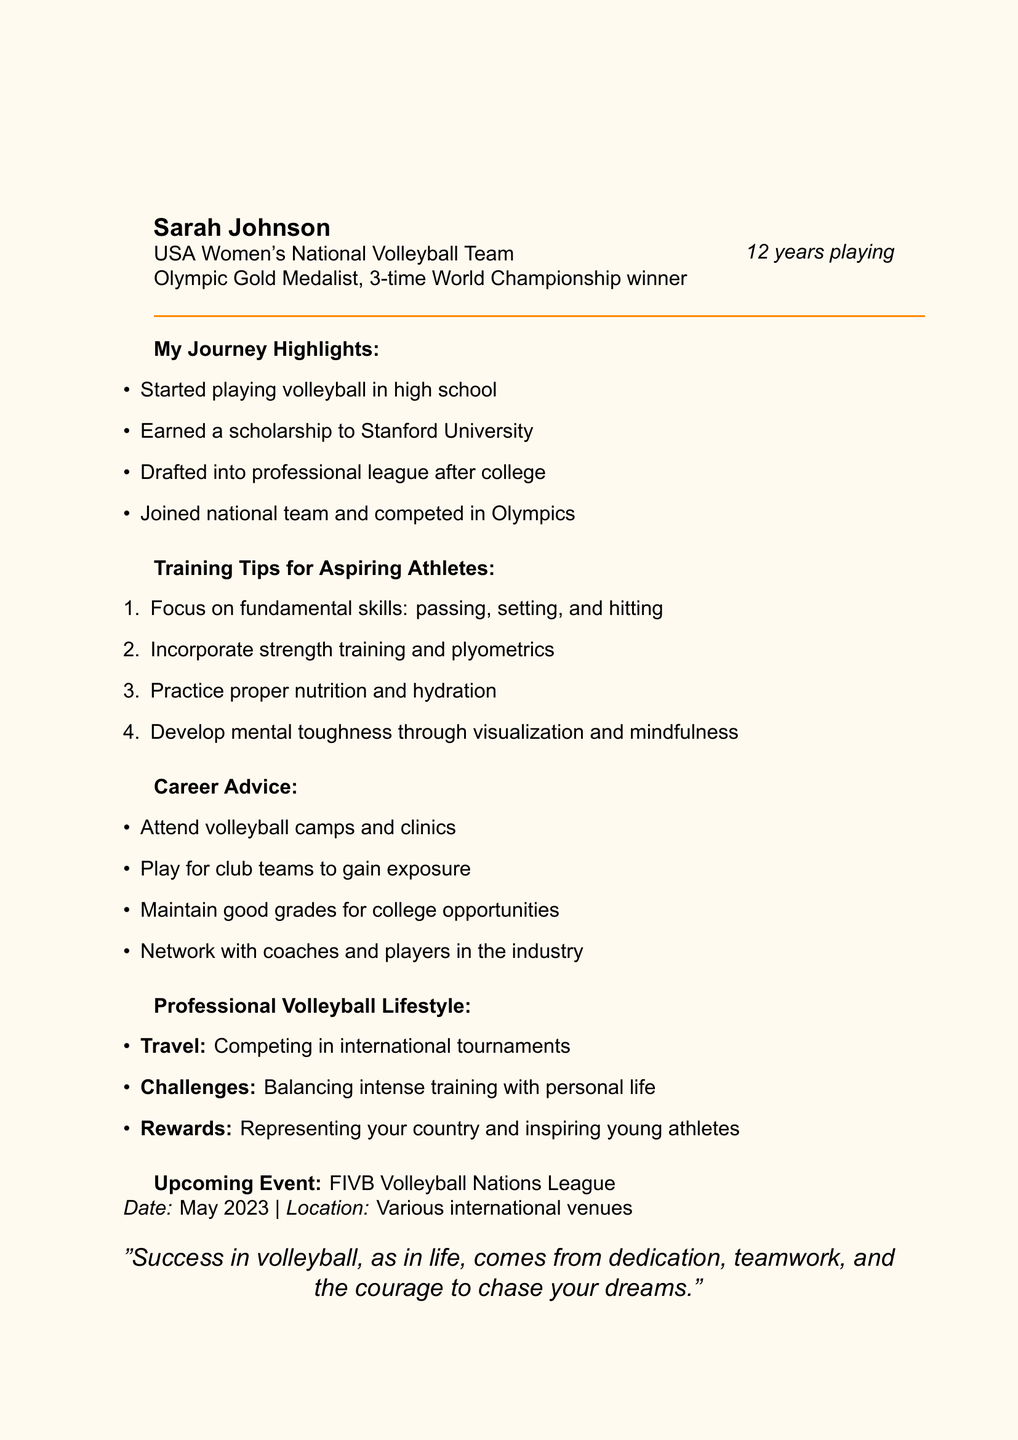What is the title of the newsletter? The title of the newsletter is stated at the beginning and is "Spike Your Dreams: Sarah Johnson's Volleyball Journey."
Answer: Spike Your Dreams: Sarah Johnson's Volleyball Journey Who is the author of the newsletter? The newsletter is written by Sarah Johnson, who is a professional volleyball player.
Answer: Sarah Johnson What achievements does Sarah Johnson have? The document lists her major achievements, including being an Olympic Gold Medalist and a 3-time World Championship winner.
Answer: Olympic Gold Medalist, 3-time World Championship winner How many years has Sarah Johnson been playing volleyball? The document states that Sarah has been playing volleyball for 12 years.
Answer: 12 years What educational institution did Sarah Johnson earn a scholarship to? The document mentions that she earned a scholarship to Stanford University.
Answer: Stanford University What are two training tips provided in the newsletter? The newsletter includes various training tips such as focusing on fundamental skills and incorporating strength training.
Answer: Focus on fundamental skills, incorporate strength training What are the challenges faced by professional volleyball players according to the newsletter? The newsletter mentions that professional players face challenges in balancing intense training with personal life.
Answer: Balancing intense training with personal life When is the upcoming event mentioned in the newsletter? The upcoming event listed in the newsletter is scheduled for May 2023.
Answer: May 2023 What is the inspirational quote shared in the newsletter? The document concludes with an inspirational quote regarding dedication, teamwork, and courage in chasing dreams.
Answer: Success in volleyball, as in life, comes from dedication, teamwork, and the courage to chase your dreams 